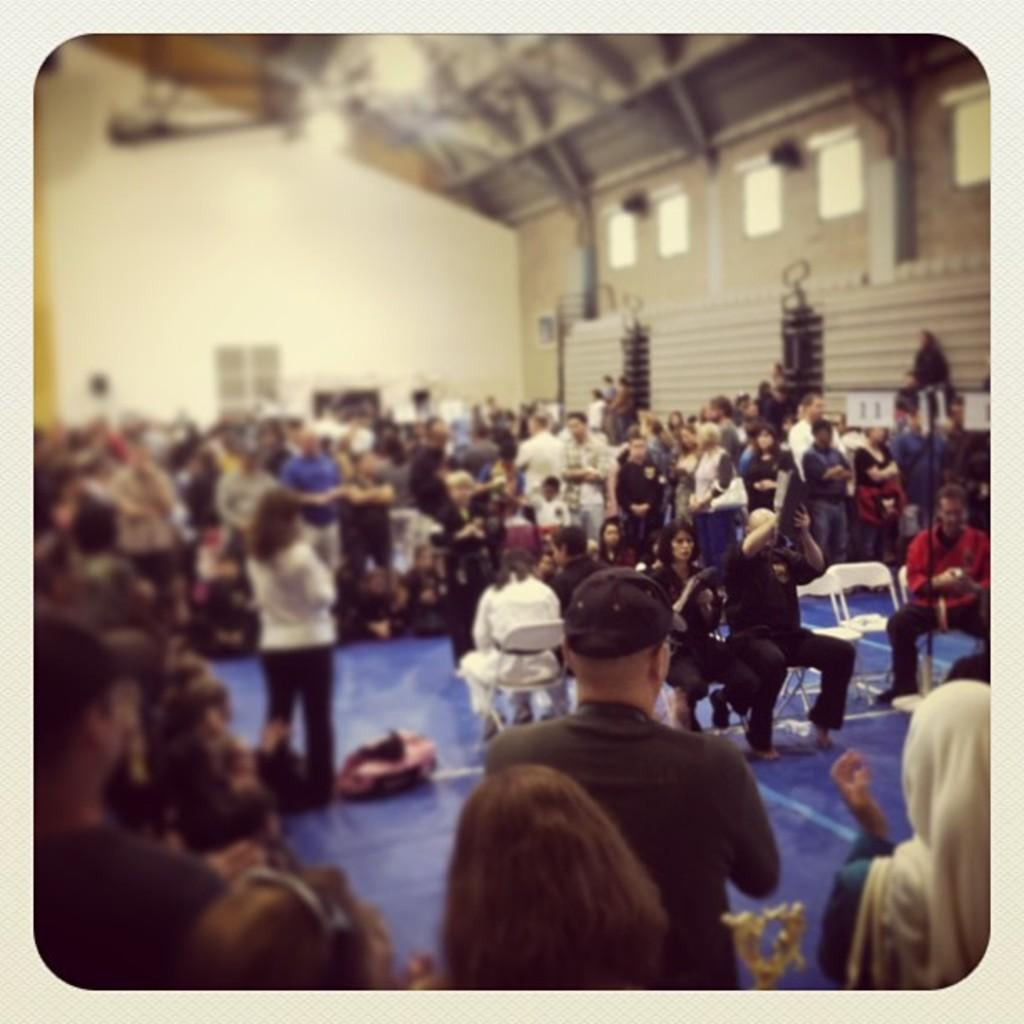How many people are in the image? There are people in the image, from left to right. What are some of the people doing in the image? Some people are sitting on chairs. What object can be seen on the floor in the image? There is a bag on the floor. What can be seen above the people in the image? There are lights visible on top (presumably referring to the ceiling or a higher location). How many ducks are sitting on the chairs with the people in the image? There are no ducks present in the image; only people are visible. What sound do the people make when they sneeze in the image? There is no indication of anyone sneezing in the image, so it cannot be determined what sound they might make. 